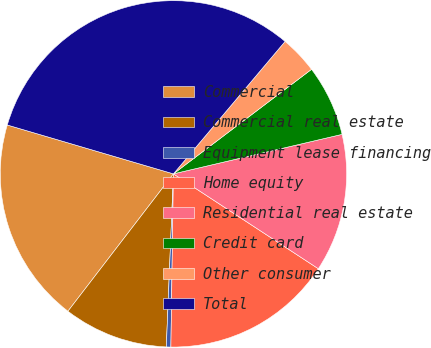<chart> <loc_0><loc_0><loc_500><loc_500><pie_chart><fcel>Commercial<fcel>Commercial real estate<fcel>Equipment lease financing<fcel>Home equity<fcel>Residential real estate<fcel>Credit card<fcel>Other consumer<fcel>Total<nl><fcel>19.13%<fcel>9.77%<fcel>0.42%<fcel>16.01%<fcel>12.89%<fcel>6.65%<fcel>3.54%<fcel>31.6%<nl></chart> 